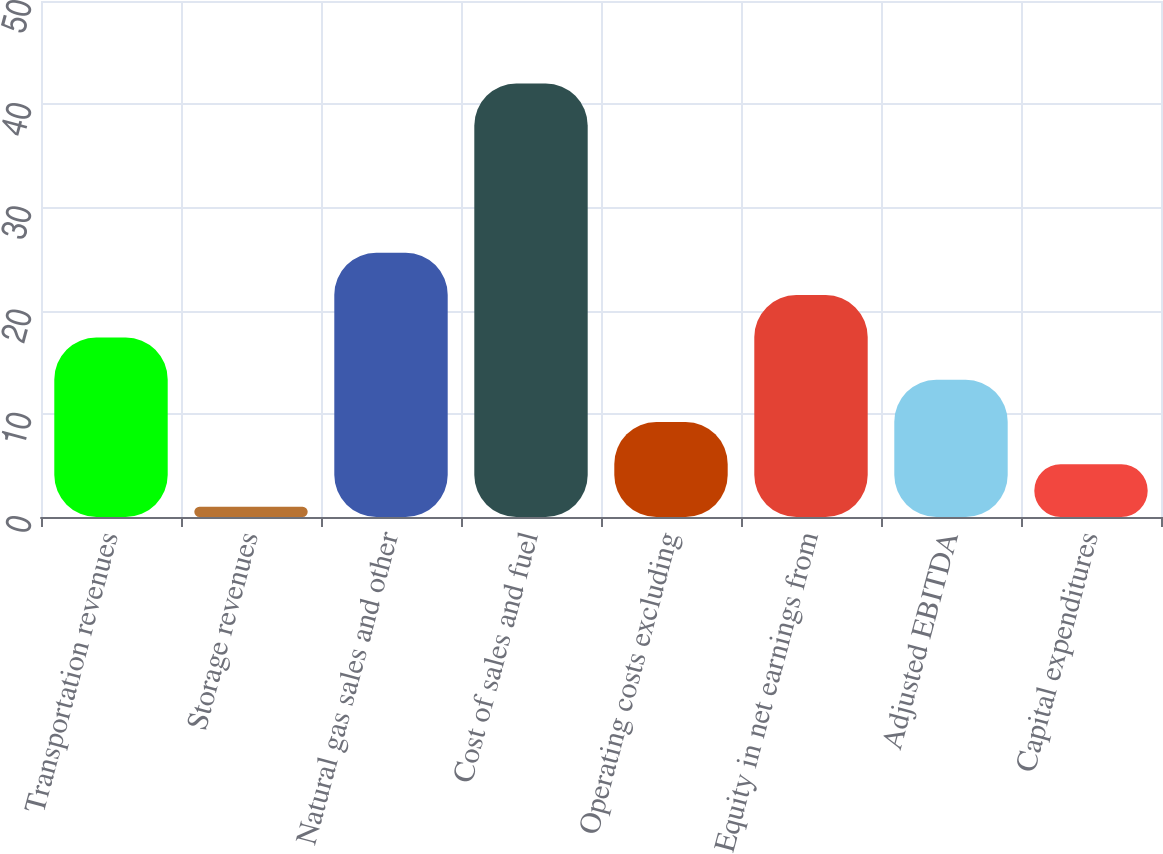Convert chart to OTSL. <chart><loc_0><loc_0><loc_500><loc_500><bar_chart><fcel>Transportation revenues<fcel>Storage revenues<fcel>Natural gas sales and other<fcel>Cost of sales and fuel<fcel>Operating costs excluding<fcel>Equity in net earnings from<fcel>Adjusted EBITDA<fcel>Capital expenditures<nl><fcel>17.4<fcel>1<fcel>25.6<fcel>42<fcel>9.2<fcel>21.5<fcel>13.3<fcel>5.1<nl></chart> 